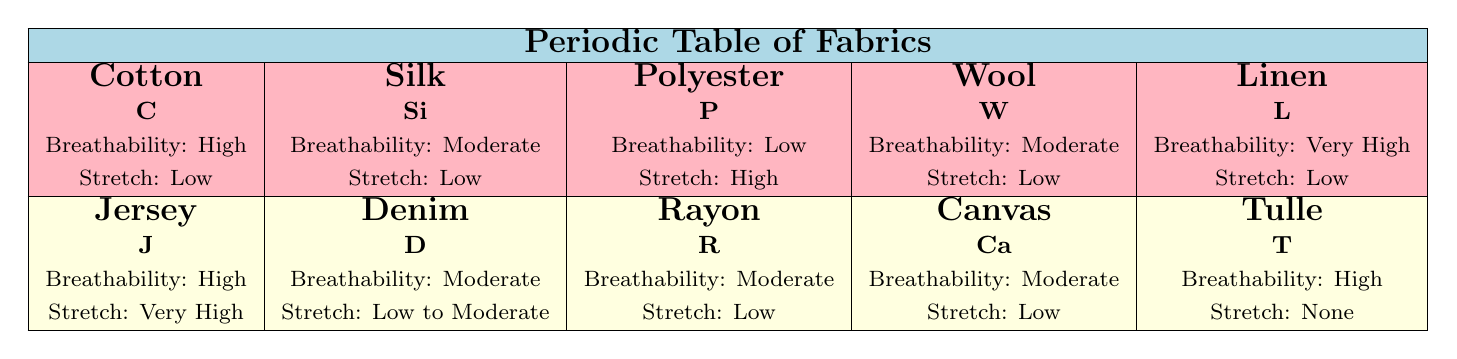What fabric has the highest breathability? By examining the breathability ratings in the table, Linen is identified with a breathability rating of "Very High," which is the highest compared to other fabrics listed.
Answer: Linen Which fabric is suitable for evening wear? Silk is explicitly listed in the "suitableGarmentStyles" for Evening Wear. Therefore, it is the correct fabric choice for that style.
Answer: Silk Does Polyester have high sustainability? In the table, Polyester is marked with "Low" for sustainability, indicating it does not have high sustainability.
Answer: No What is the average stretch value of fabrics suitable for casual wear? The fabrics suitable for casual wear listed are Cotton (Low), Jersey (Very High), and Tulle (None). To find the average stretch, we assign values: Low = 1, Very High = 3, None = 0. The average is calculated as (1 + 3 + 0) / 3, which equals approximately 1.33.
Answer: 1.33 Is there a fabric that is suitable for both summer dresses and shirts? Referring to the suitable garment styles, Linen is suitable for Summer Dresses and Cotton is suitable for Shirts. However, Cotton is not listed for summer dresses, while Linen is not suitable for shirts. Thus, there is no single fabric fitting both categories.
Answer: No What is the most suitable fabric for skirts? Tulle and Denim are both listed in the "suitableGarmentStyles" for Skirts. Therefore, the suitable fabrics for skirts can be either of these two.
Answer: Tulle and Denim Is Wool suitable for activewear? The table indicates that Wool is specifically suitable for Coats, Sweaters, and Formal Wear but does not mention Activewear, which means it is not suitable for such.
Answer: No Which fabric has a moderate drape and is suitable for setting up travel wear? Polyester has a "Moderate" drape rating and is also listed as suitable for "Travel Wear" within its garment styles. Thus, it meets both criteria.
Answer: Polyester 